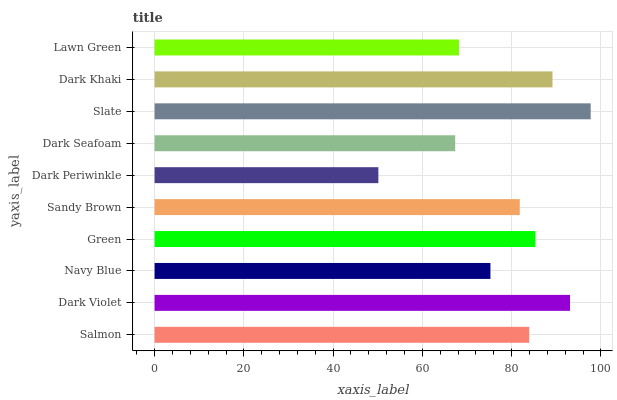Is Dark Periwinkle the minimum?
Answer yes or no. Yes. Is Slate the maximum?
Answer yes or no. Yes. Is Dark Violet the minimum?
Answer yes or no. No. Is Dark Violet the maximum?
Answer yes or no. No. Is Dark Violet greater than Salmon?
Answer yes or no. Yes. Is Salmon less than Dark Violet?
Answer yes or no. Yes. Is Salmon greater than Dark Violet?
Answer yes or no. No. Is Dark Violet less than Salmon?
Answer yes or no. No. Is Salmon the high median?
Answer yes or no. Yes. Is Sandy Brown the low median?
Answer yes or no. Yes. Is Dark Khaki the high median?
Answer yes or no. No. Is Dark Khaki the low median?
Answer yes or no. No. 